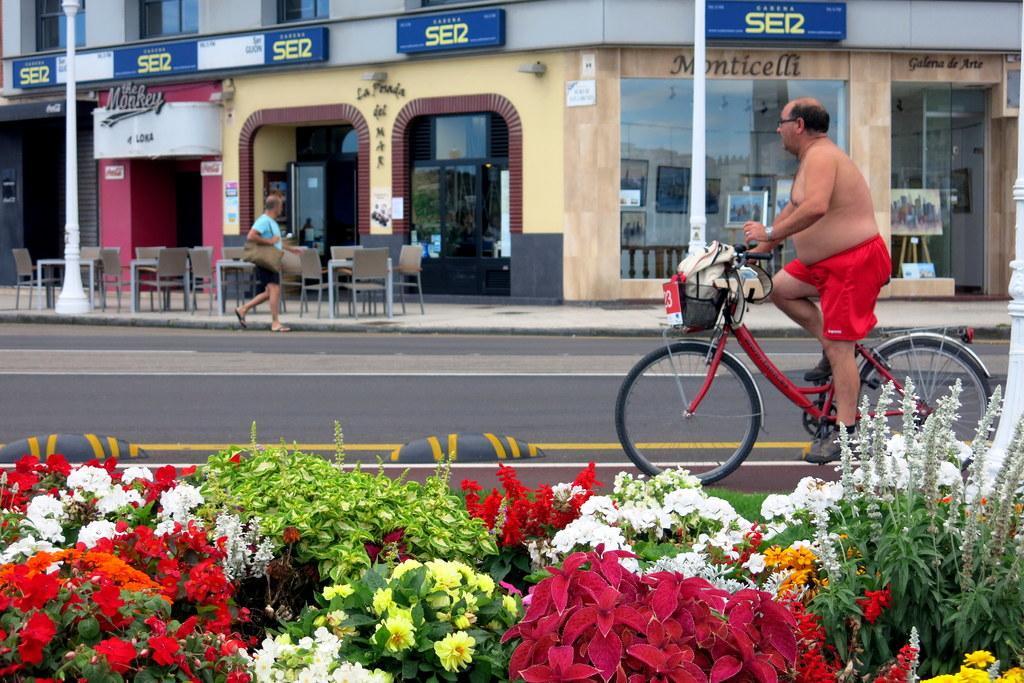Describe this image in one or two sentences. A man is riding a bicycle on a road. He is carrying a bag on it. There are some flower plants beside the road. A man at a distance is passing by a restaurant. There are some tables and chairs in front of the restaurant. 